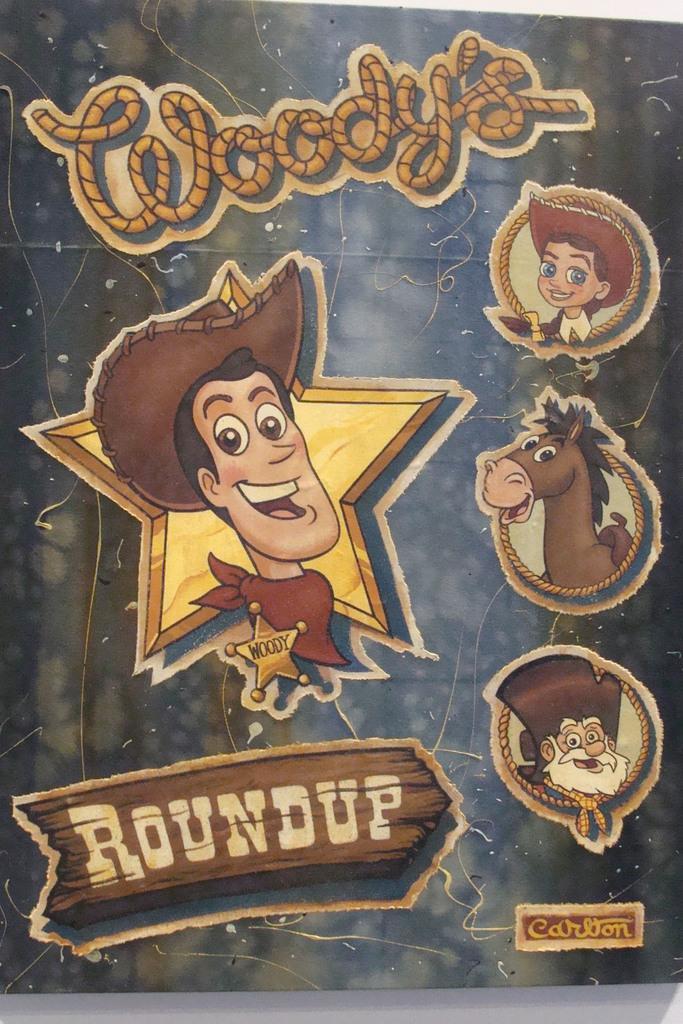Describe this image in one or two sentences. In this image I can see a poster which is brown, cream and black in color. In that poster I can see a person, a animal, a boy and a person with white beard. 